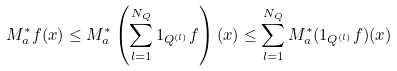<formula> <loc_0><loc_0><loc_500><loc_500>M _ { a } ^ { * } f ( x ) \leq M _ { a } ^ { * } \left ( \sum _ { l = 1 } ^ { N _ { Q } } 1 _ { Q ^ { ( l ) } } f \right ) ( x ) \leq \sum _ { l = 1 } ^ { N _ { Q } } M _ { a } ^ { * } ( 1 _ { Q ^ { ( l ) } } f ) ( x )</formula> 